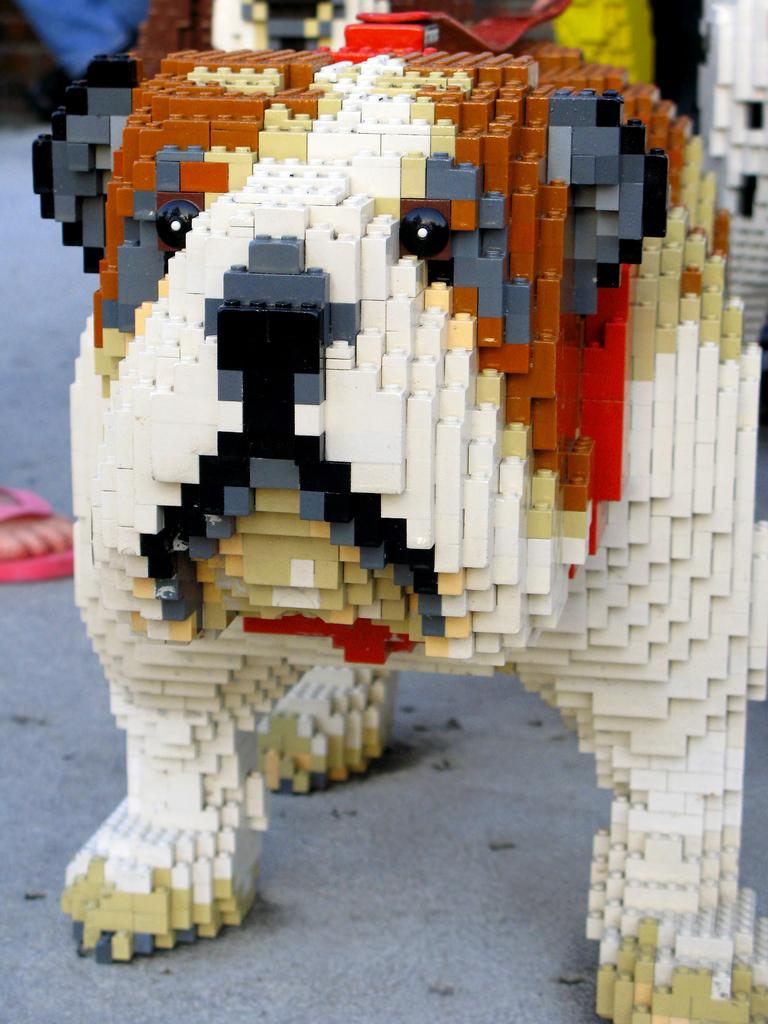What type of toy is featured in the image? There are building blocks in the image. What shape do the building blocks form? The building blocks are shaped like a dog. What can be observed about the colors of the building blocks? The building blocks are in different colors. Where is the trail that the dog is walking on in the image? There is no trail or dog walking in the image; it features building blocks shaped like a dog. How many hours of sleep can be seen in the image? There is no indication of sleep or a sleeping creature in the image. 